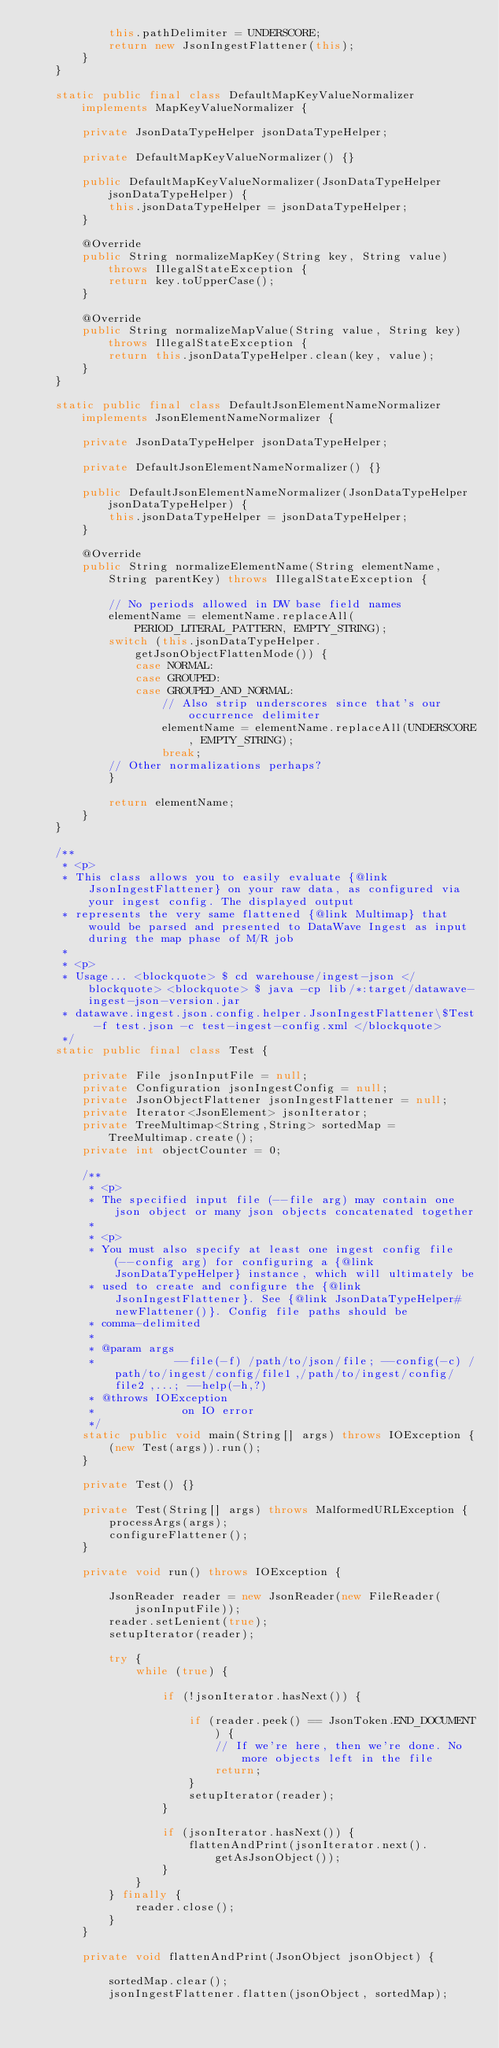<code> <loc_0><loc_0><loc_500><loc_500><_Java_>            this.pathDelimiter = UNDERSCORE;
            return new JsonIngestFlattener(this);
        }
    }
    
    static public final class DefaultMapKeyValueNormalizer implements MapKeyValueNormalizer {
        
        private JsonDataTypeHelper jsonDataTypeHelper;
        
        private DefaultMapKeyValueNormalizer() {}
        
        public DefaultMapKeyValueNormalizer(JsonDataTypeHelper jsonDataTypeHelper) {
            this.jsonDataTypeHelper = jsonDataTypeHelper;
        }
        
        @Override
        public String normalizeMapKey(String key, String value) throws IllegalStateException {
            return key.toUpperCase();
        }
        
        @Override
        public String normalizeMapValue(String value, String key) throws IllegalStateException {
            return this.jsonDataTypeHelper.clean(key, value);
        }
    }
    
    static public final class DefaultJsonElementNameNormalizer implements JsonElementNameNormalizer {
        
        private JsonDataTypeHelper jsonDataTypeHelper;
        
        private DefaultJsonElementNameNormalizer() {}
        
        public DefaultJsonElementNameNormalizer(JsonDataTypeHelper jsonDataTypeHelper) {
            this.jsonDataTypeHelper = jsonDataTypeHelper;
        }
        
        @Override
        public String normalizeElementName(String elementName, String parentKey) throws IllegalStateException {
            
            // No periods allowed in DW base field names
            elementName = elementName.replaceAll(PERIOD_LITERAL_PATTERN, EMPTY_STRING);
            switch (this.jsonDataTypeHelper.getJsonObjectFlattenMode()) {
                case NORMAL:
                case GROUPED:
                case GROUPED_AND_NORMAL:
                    // Also strip underscores since that's our occurrence delimiter
                    elementName = elementName.replaceAll(UNDERSCORE, EMPTY_STRING);
                    break;
            // Other normalizations perhaps?
            }
            
            return elementName;
        }
    }
    
    /**
     * <p>
     * This class allows you to easily evaluate {@link JsonIngestFlattener} on your raw data, as configured via your ingest config. The displayed output
     * represents the very same flattened {@link Multimap} that would be parsed and presented to DataWave Ingest as input during the map phase of M/R job
     *
     * <p>
     * Usage... <blockquote> $ cd warehouse/ingest-json </blockquote> <blockquote> $ java -cp lib/*:target/datawave-ingest-json-version.jar
     * datawave.ingest.json.config.helper.JsonIngestFlattener\$Test -f test.json -c test-ingest-config.xml </blockquote>
     */
    static public final class Test {
        
        private File jsonInputFile = null;
        private Configuration jsonIngestConfig = null;
        private JsonObjectFlattener jsonIngestFlattener = null;
        private Iterator<JsonElement> jsonIterator;
        private TreeMultimap<String,String> sortedMap = TreeMultimap.create();
        private int objectCounter = 0;
        
        /**
         * <p>
         * The specified input file (--file arg) may contain one json object or many json objects concatenated together
         *
         * <p>
         * You must also specify at least one ingest config file (--config arg) for configuring a {@link JsonDataTypeHelper} instance, which will ultimately be
         * used to create and configure the {@link JsonIngestFlattener}. See {@link JsonDataTypeHelper#newFlattener()}. Config file paths should be
         * comma-delimited
         *
         * @param args
         *            --file(-f) /path/to/json/file; --config(-c) /path/to/ingest/config/file1,/path/to/ingest/config/file2,...; --help(-h,?)
         * @throws IOException
         *             on IO error
         */
        static public void main(String[] args) throws IOException {
            (new Test(args)).run();
        }
        
        private Test() {}
        
        private Test(String[] args) throws MalformedURLException {
            processArgs(args);
            configureFlattener();
        }
        
        private void run() throws IOException {
            
            JsonReader reader = new JsonReader(new FileReader(jsonInputFile));
            reader.setLenient(true);
            setupIterator(reader);
            
            try {
                while (true) {
                    
                    if (!jsonIterator.hasNext()) {
                        
                        if (reader.peek() == JsonToken.END_DOCUMENT) {
                            // If we're here, then we're done. No more objects left in the file
                            return;
                        }
                        setupIterator(reader);
                    }
                    
                    if (jsonIterator.hasNext()) {
                        flattenAndPrint(jsonIterator.next().getAsJsonObject());
                    }
                }
            } finally {
                reader.close();
            }
        }
        
        private void flattenAndPrint(JsonObject jsonObject) {
            
            sortedMap.clear();
            jsonIngestFlattener.flatten(jsonObject, sortedMap);
            </code> 